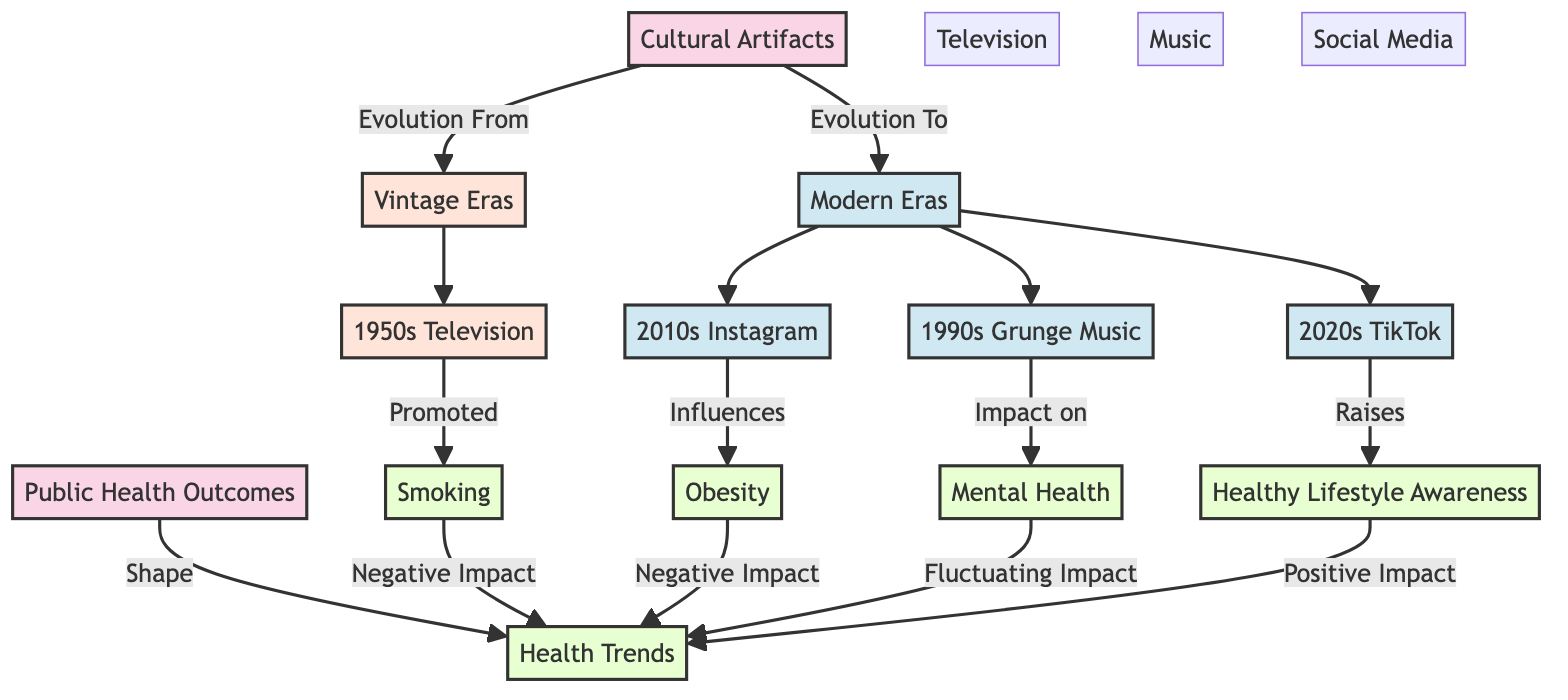What are the two main categories of cultural artifacts in the diagram? The diagram identifies two main categories of cultural artifacts: vintage eras and modern eras, both of which are connected to the node "Cultural Artifacts."
Answer: vintage eras and modern eras Which cultural artifact is associated with the 1950s? The node specifically indicates that "1950s Television" is associated with the vintage era in this diagram.
Answer: 1950s Television What health trend is most negatively impacted by smoking? According to the diagram, smoking has a direct relationship causing a negative impact on health trends.
Answer: negative impact How many modern cultural artifacts are represented in the diagram? The modern cultural artifacts in the diagram are Grunge Music from the 1990s, Instagram from the 2010s, and TikTok from the 2020s—counting these provides a total of three.
Answer: three Which recent social media platform is noted for raising healthy lifestyle awareness? The diagram indicates that TikTok from the 2020s is recognized for raising healthy lifestyle awareness.
Answer: TikTok What is the overall influence of obesity on health trends according to this diagram? The flow from the obesity node shows that it has a negative impact on health trends, demonstrating an adverse correlation.
Answer: negative impact Which cultural artifact from the modern era is linked with mental health? The diagram connects "1990s Grunge Music" from the modern era directly to mental health, specifying its impact.
Answer: 1990s Grunge Music How does the evolution of cultural artifacts affect public health outcomes? The diagram illustrates that cultural artifacts evolve from vintage to modern, which subsequently shapes public health outcomes and health trends.
Answer: shapes public health outcomes What is the relationship depicted between public health outcomes and health trends? The arrow indicates a direct influence where public health outcomes shape health trends, thereby establishing a clear connection.
Answer: shape What are the health outcomes negatively impacted according to the vintage and modern cultural artifacts? The diagram lists smoking and obesity as negatively impacting health trends, highlighting their adverse effects.
Answer: smoking and obesity 